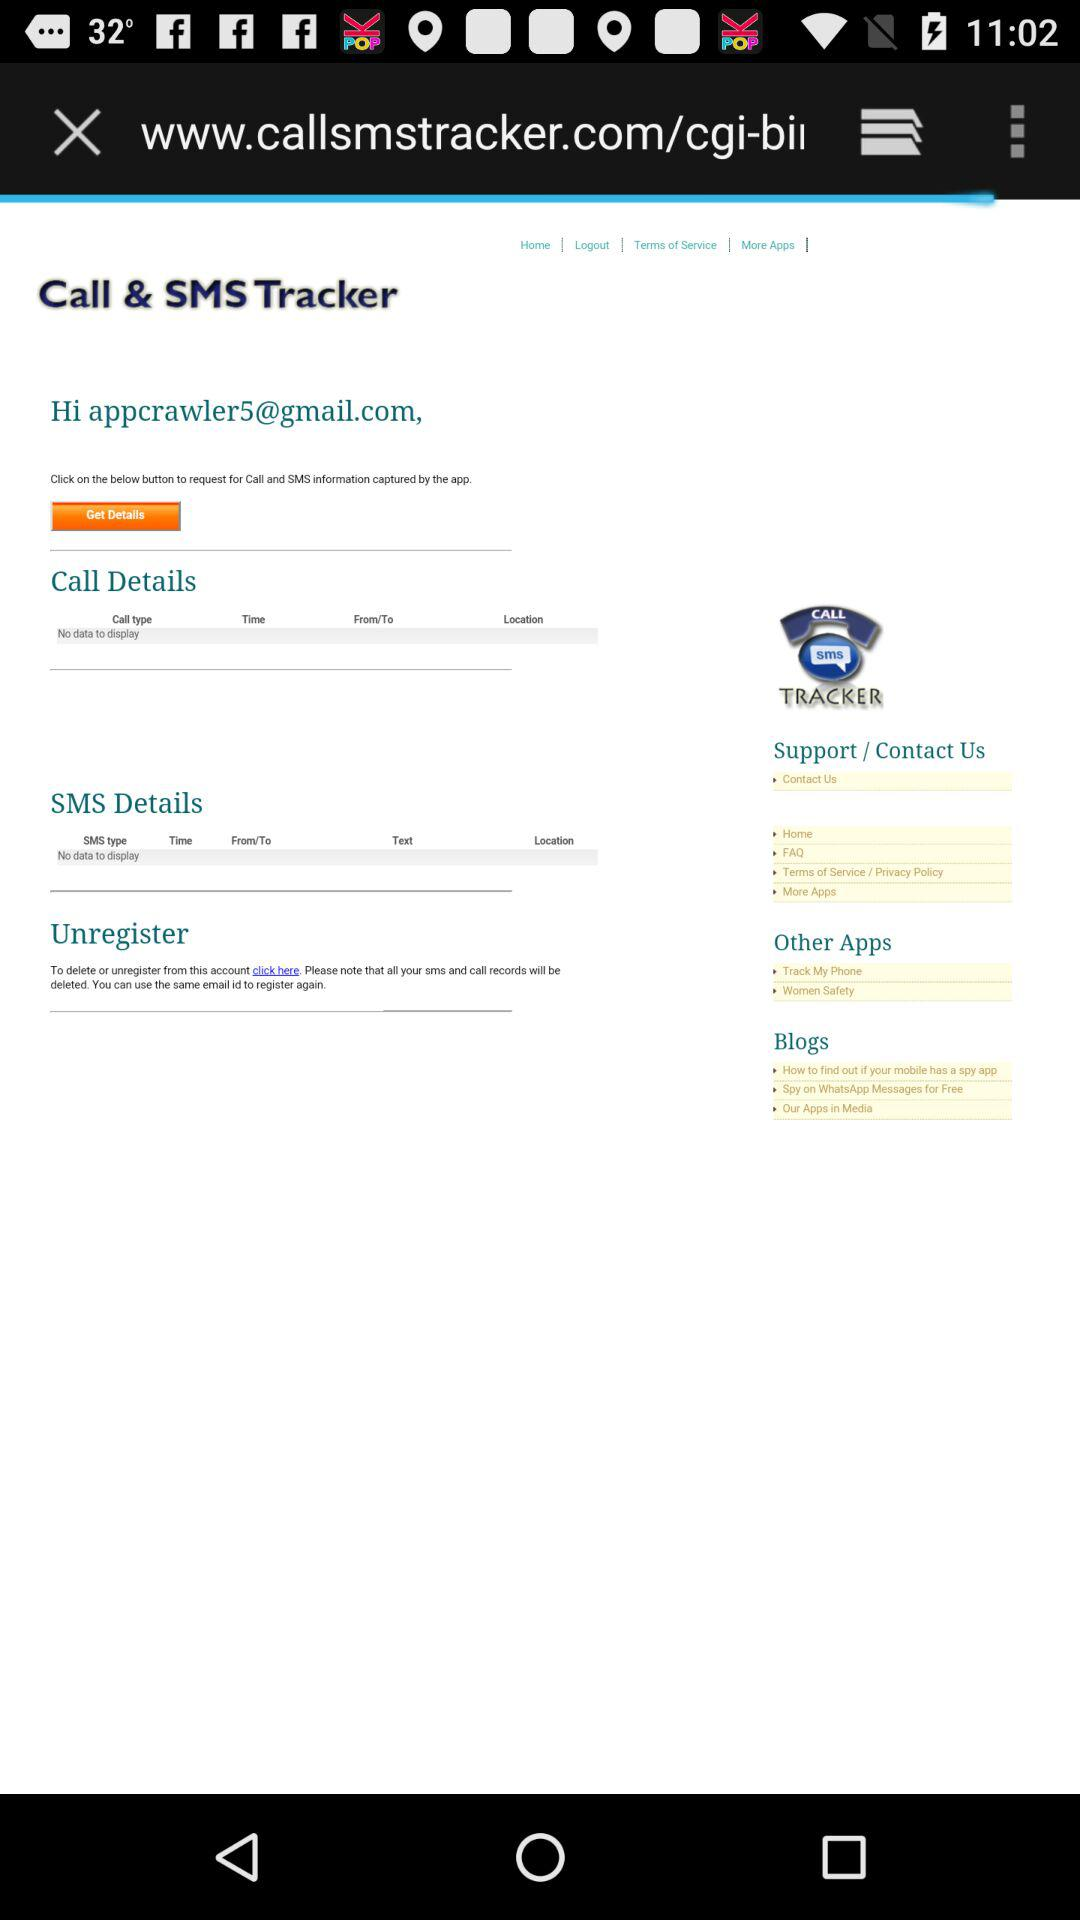What is the email address? The email address is appcrawler5@gmail.com. 